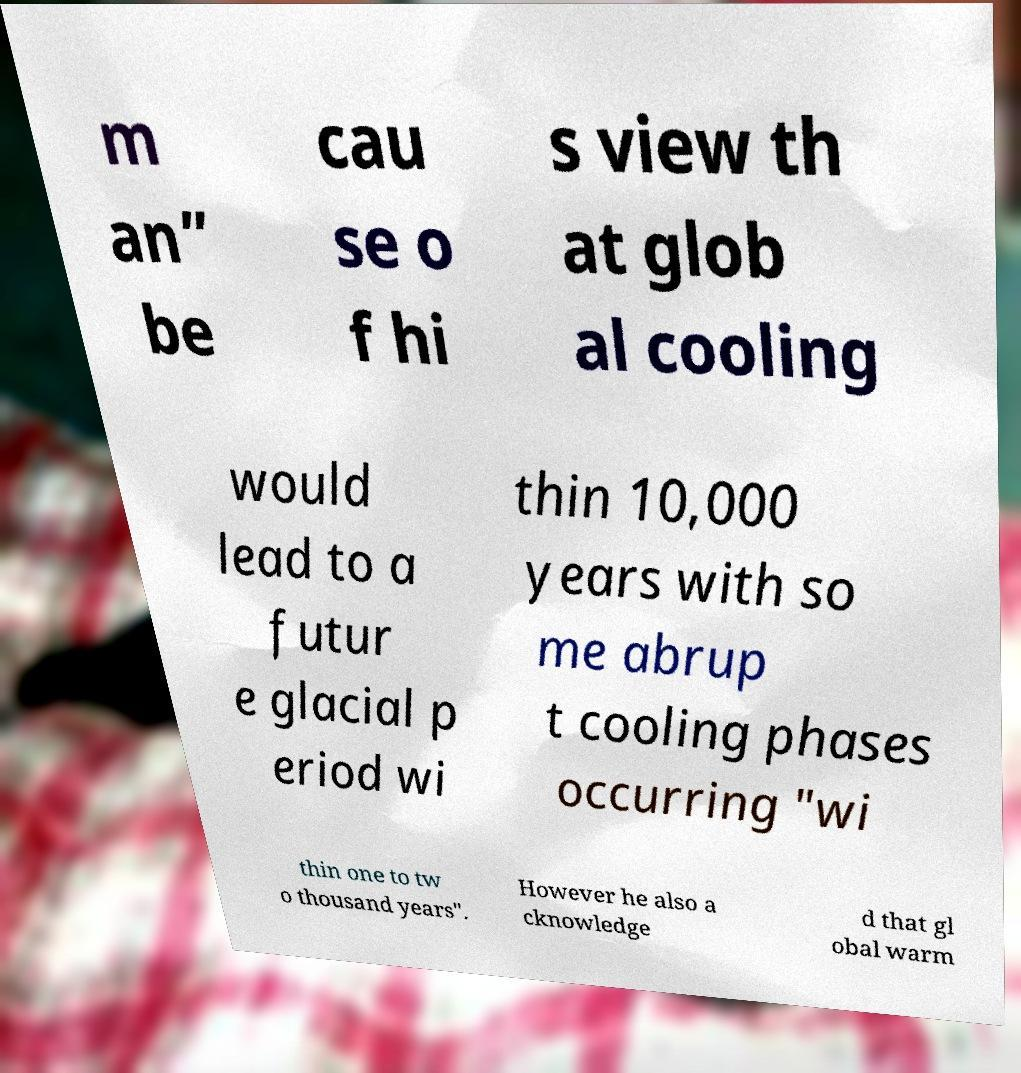Please identify and transcribe the text found in this image. m an” be cau se o f hi s view th at glob al cooling would lead to a futur e glacial p eriod wi thin 10,000 years with so me abrup t cooling phases occurring "wi thin one to tw o thousand years". However he also a cknowledge d that gl obal warm 